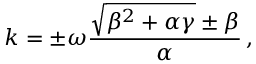Convert formula to latex. <formula><loc_0><loc_0><loc_500><loc_500>k = \pm \omega \frac { \sqrt { \beta ^ { 2 } + \alpha \gamma } \pm \beta } { \alpha } \, ,</formula> 